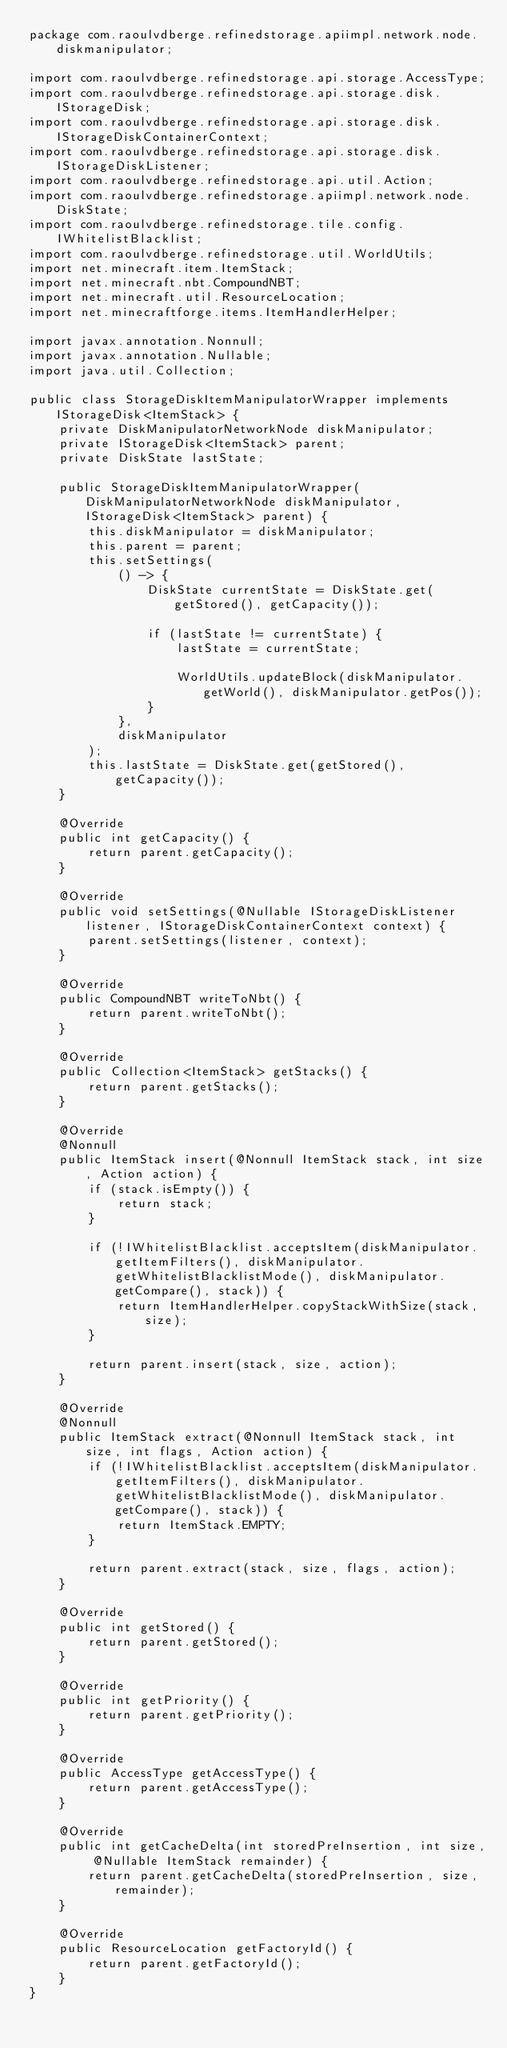Convert code to text. <code><loc_0><loc_0><loc_500><loc_500><_Java_>package com.raoulvdberge.refinedstorage.apiimpl.network.node.diskmanipulator;

import com.raoulvdberge.refinedstorage.api.storage.AccessType;
import com.raoulvdberge.refinedstorage.api.storage.disk.IStorageDisk;
import com.raoulvdberge.refinedstorage.api.storage.disk.IStorageDiskContainerContext;
import com.raoulvdberge.refinedstorage.api.storage.disk.IStorageDiskListener;
import com.raoulvdberge.refinedstorage.api.util.Action;
import com.raoulvdberge.refinedstorage.apiimpl.network.node.DiskState;
import com.raoulvdberge.refinedstorage.tile.config.IWhitelistBlacklist;
import com.raoulvdberge.refinedstorage.util.WorldUtils;
import net.minecraft.item.ItemStack;
import net.minecraft.nbt.CompoundNBT;
import net.minecraft.util.ResourceLocation;
import net.minecraftforge.items.ItemHandlerHelper;

import javax.annotation.Nonnull;
import javax.annotation.Nullable;
import java.util.Collection;

public class StorageDiskItemManipulatorWrapper implements IStorageDisk<ItemStack> {
    private DiskManipulatorNetworkNode diskManipulator;
    private IStorageDisk<ItemStack> parent;
    private DiskState lastState;

    public StorageDiskItemManipulatorWrapper(DiskManipulatorNetworkNode diskManipulator, IStorageDisk<ItemStack> parent) {
        this.diskManipulator = diskManipulator;
        this.parent = parent;
        this.setSettings(
            () -> {
                DiskState currentState = DiskState.get(getStored(), getCapacity());

                if (lastState != currentState) {
                    lastState = currentState;

                    WorldUtils.updateBlock(diskManipulator.getWorld(), diskManipulator.getPos());
                }
            },
            diskManipulator
        );
        this.lastState = DiskState.get(getStored(), getCapacity());
    }

    @Override
    public int getCapacity() {
        return parent.getCapacity();
    }

    @Override
    public void setSettings(@Nullable IStorageDiskListener listener, IStorageDiskContainerContext context) {
        parent.setSettings(listener, context);
    }

    @Override
    public CompoundNBT writeToNbt() {
        return parent.writeToNbt();
    }

    @Override
    public Collection<ItemStack> getStacks() {
        return parent.getStacks();
    }

    @Override
    @Nonnull
    public ItemStack insert(@Nonnull ItemStack stack, int size, Action action) {
        if (stack.isEmpty()) {
            return stack;
        }

        if (!IWhitelistBlacklist.acceptsItem(diskManipulator.getItemFilters(), diskManipulator.getWhitelistBlacklistMode(), diskManipulator.getCompare(), stack)) {
            return ItemHandlerHelper.copyStackWithSize(stack, size);
        }

        return parent.insert(stack, size, action);
    }

    @Override
    @Nonnull
    public ItemStack extract(@Nonnull ItemStack stack, int size, int flags, Action action) {
        if (!IWhitelistBlacklist.acceptsItem(diskManipulator.getItemFilters(), diskManipulator.getWhitelistBlacklistMode(), diskManipulator.getCompare(), stack)) {
            return ItemStack.EMPTY;
        }

        return parent.extract(stack, size, flags, action);
    }

    @Override
    public int getStored() {
        return parent.getStored();
    }

    @Override
    public int getPriority() {
        return parent.getPriority();
    }

    @Override
    public AccessType getAccessType() {
        return parent.getAccessType();
    }

    @Override
    public int getCacheDelta(int storedPreInsertion, int size, @Nullable ItemStack remainder) {
        return parent.getCacheDelta(storedPreInsertion, size, remainder);
    }

    @Override
    public ResourceLocation getFactoryId() {
        return parent.getFactoryId();
    }
}
</code> 